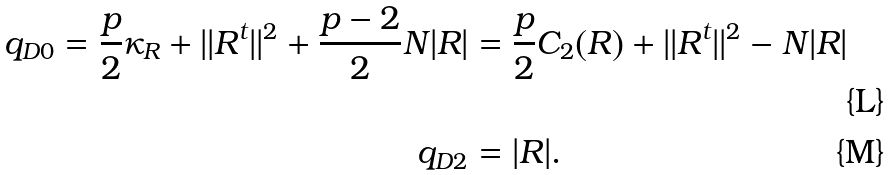<formula> <loc_0><loc_0><loc_500><loc_500>q _ { D 0 } = \frac { p } { 2 } \kappa _ { R } + | | R ^ { t } | | ^ { 2 } + \frac { p - 2 } { 2 } N | R | & = \frac { p } { 2 } C _ { 2 } ( R ) + | | R ^ { t } | | ^ { 2 } - N | R | \\ q _ { D 2 } & = | R | .</formula> 